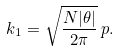<formula> <loc_0><loc_0><loc_500><loc_500>k _ { 1 } = \sqrt { \frac { N | \theta | } { 2 \pi } } \, p .</formula> 